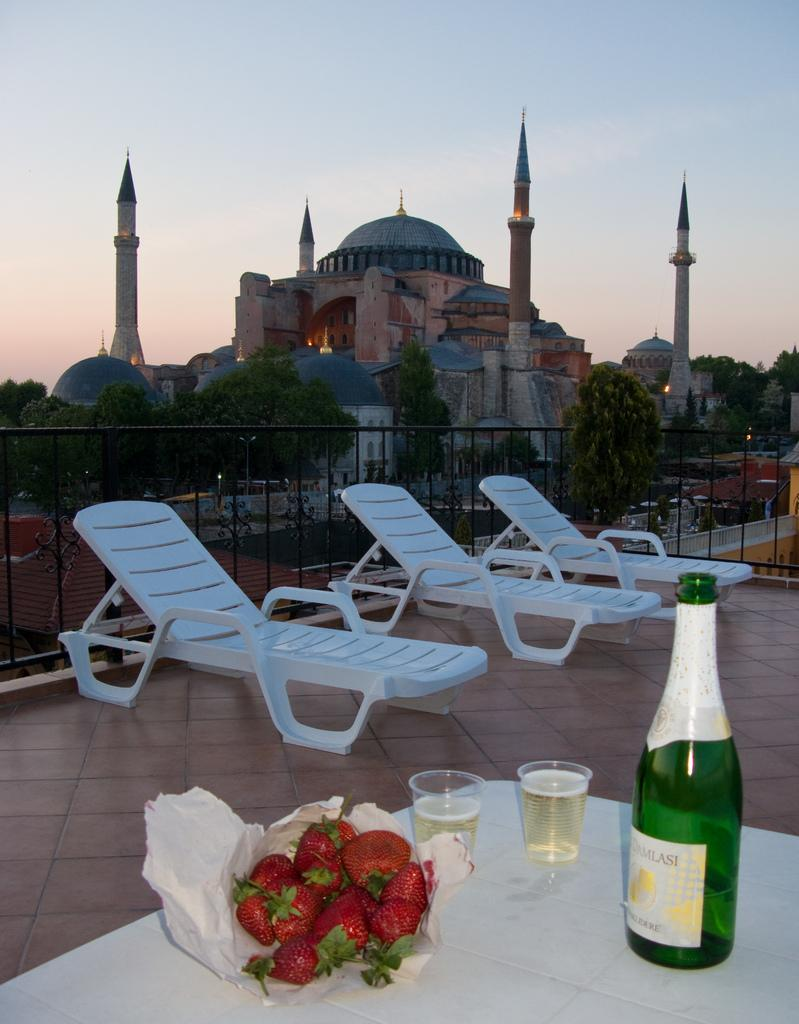What is one of the objects visible in the image? There is a bottle in the image. What else can be seen on the table in the image? There are glasses and strawberries visible on the table. Where are the objects located in the image? The objects are on a table. What can be seen in the background of the image? There are chairs, trees, and a building visible in the background of the image. What type of doll is sitting on the pail in the image? There is no doll or pail present in the image. 